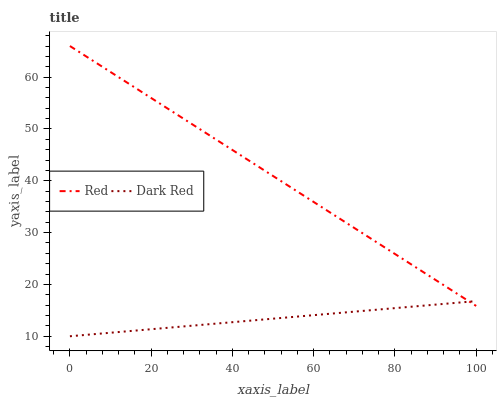Does Dark Red have the minimum area under the curve?
Answer yes or no. Yes. Does Red have the maximum area under the curve?
Answer yes or no. Yes. Does Red have the minimum area under the curve?
Answer yes or no. No. Is Dark Red the smoothest?
Answer yes or no. Yes. Is Red the roughest?
Answer yes or no. Yes. Is Red the smoothest?
Answer yes or no. No. Does Red have the lowest value?
Answer yes or no. No. 